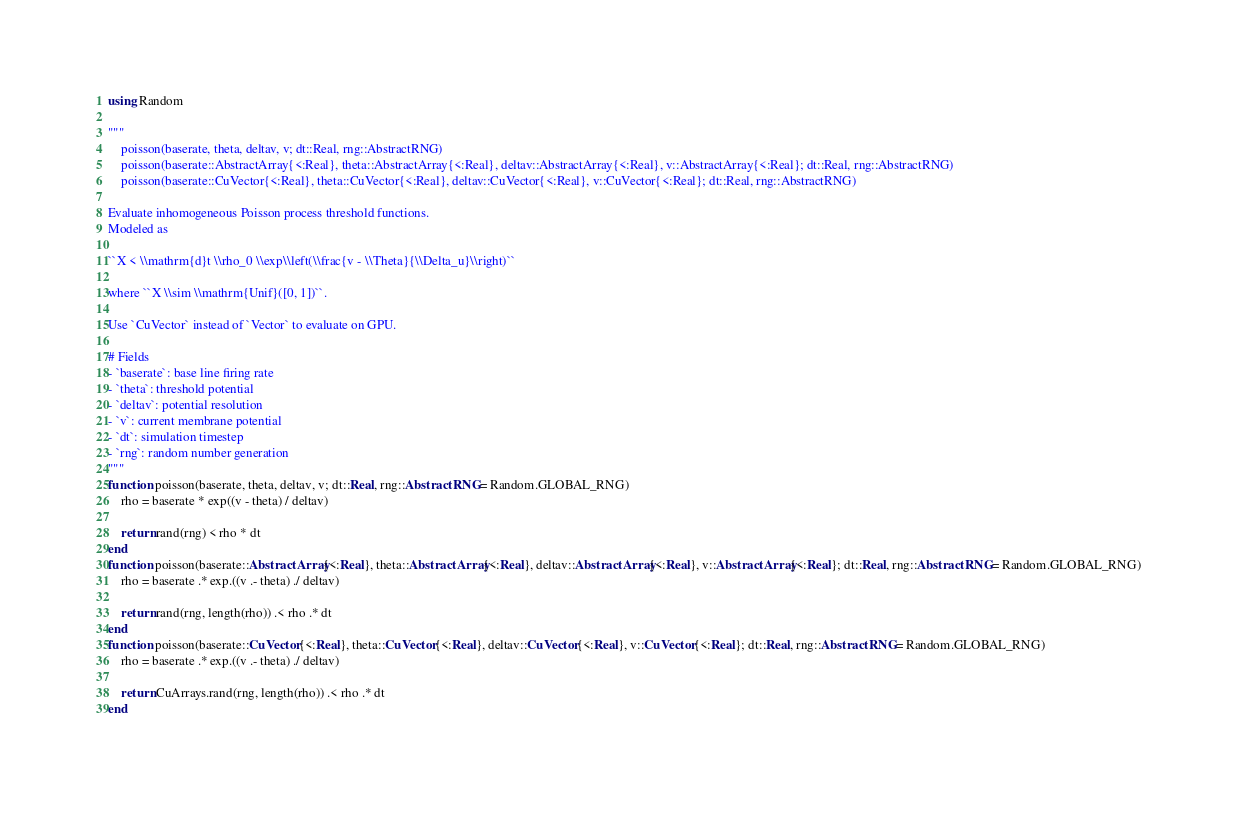Convert code to text. <code><loc_0><loc_0><loc_500><loc_500><_Julia_>using Random

"""
    poisson(baserate, theta, deltav, v; dt::Real, rng::AbstractRNG)
    poisson(baserate::AbstractArray{<:Real}, theta::AbstractArray{<:Real}, deltav::AbstractArray{<:Real}, v::AbstractArray{<:Real}; dt::Real, rng::AbstractRNG)
    poisson(baserate::CuVector{<:Real}, theta::CuVector{<:Real}, deltav::CuVector{<:Real}, v::CuVector{<:Real}; dt::Real, rng::AbstractRNG)

Evaluate inhomogeneous Poisson process threshold functions.
Modeled as

``X < \\mathrm{d}t \\rho_0 \\exp\\left(\\frac{v - \\Theta}{\\Delta_u}\\right)``

where ``X \\sim \\mathrm{Unif}([0, 1])``.

Use `CuVector` instead of `Vector` to evaluate on GPU.

# Fields
- `baserate`: base line firing rate
- `theta`: threshold potential
- `deltav`: potential resolution
- `v`: current membrane potential
- `dt`: simulation timestep
- `rng`: random number generation
"""
function poisson(baserate, theta, deltav, v; dt::Real, rng::AbstractRNG = Random.GLOBAL_RNG)
    rho = baserate * exp((v - theta) / deltav)

    return rand(rng) < rho * dt
end
function poisson(baserate::AbstractArray{<:Real}, theta::AbstractArray{<:Real}, deltav::AbstractArray{<:Real}, v::AbstractArray{<:Real}; dt::Real, rng::AbstractRNG = Random.GLOBAL_RNG)
    rho = baserate .* exp.((v .- theta) ./ deltav)

    return rand(rng, length(rho)) .< rho .* dt
end
function poisson(baserate::CuVector{<:Real}, theta::CuVector{<:Real}, deltav::CuVector{<:Real}, v::CuVector{<:Real}; dt::Real, rng::AbstractRNG = Random.GLOBAL_RNG)
    rho = baserate .* exp.((v .- theta) ./ deltav)

    return CuArrays.rand(rng, length(rho)) .< rho .* dt
end</code> 